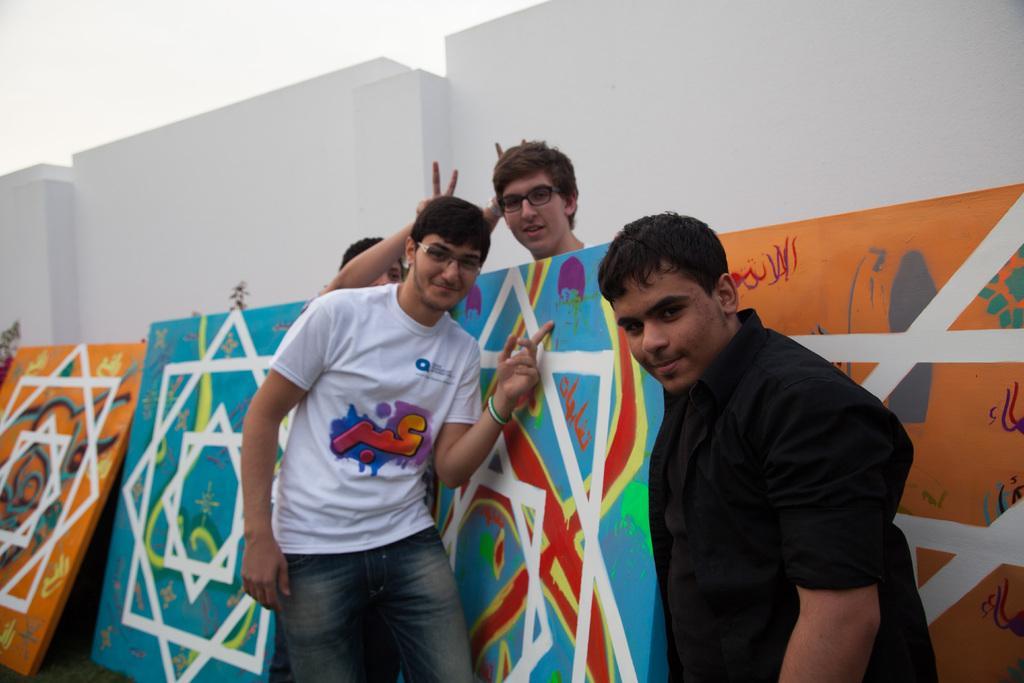Please provide a concise description of this image. In the foreground of the picture there are two person standing, behind them there are paintings. Behind the paintings there are two people standing. At the background there is a wall painted white. Sky is cloudy. 